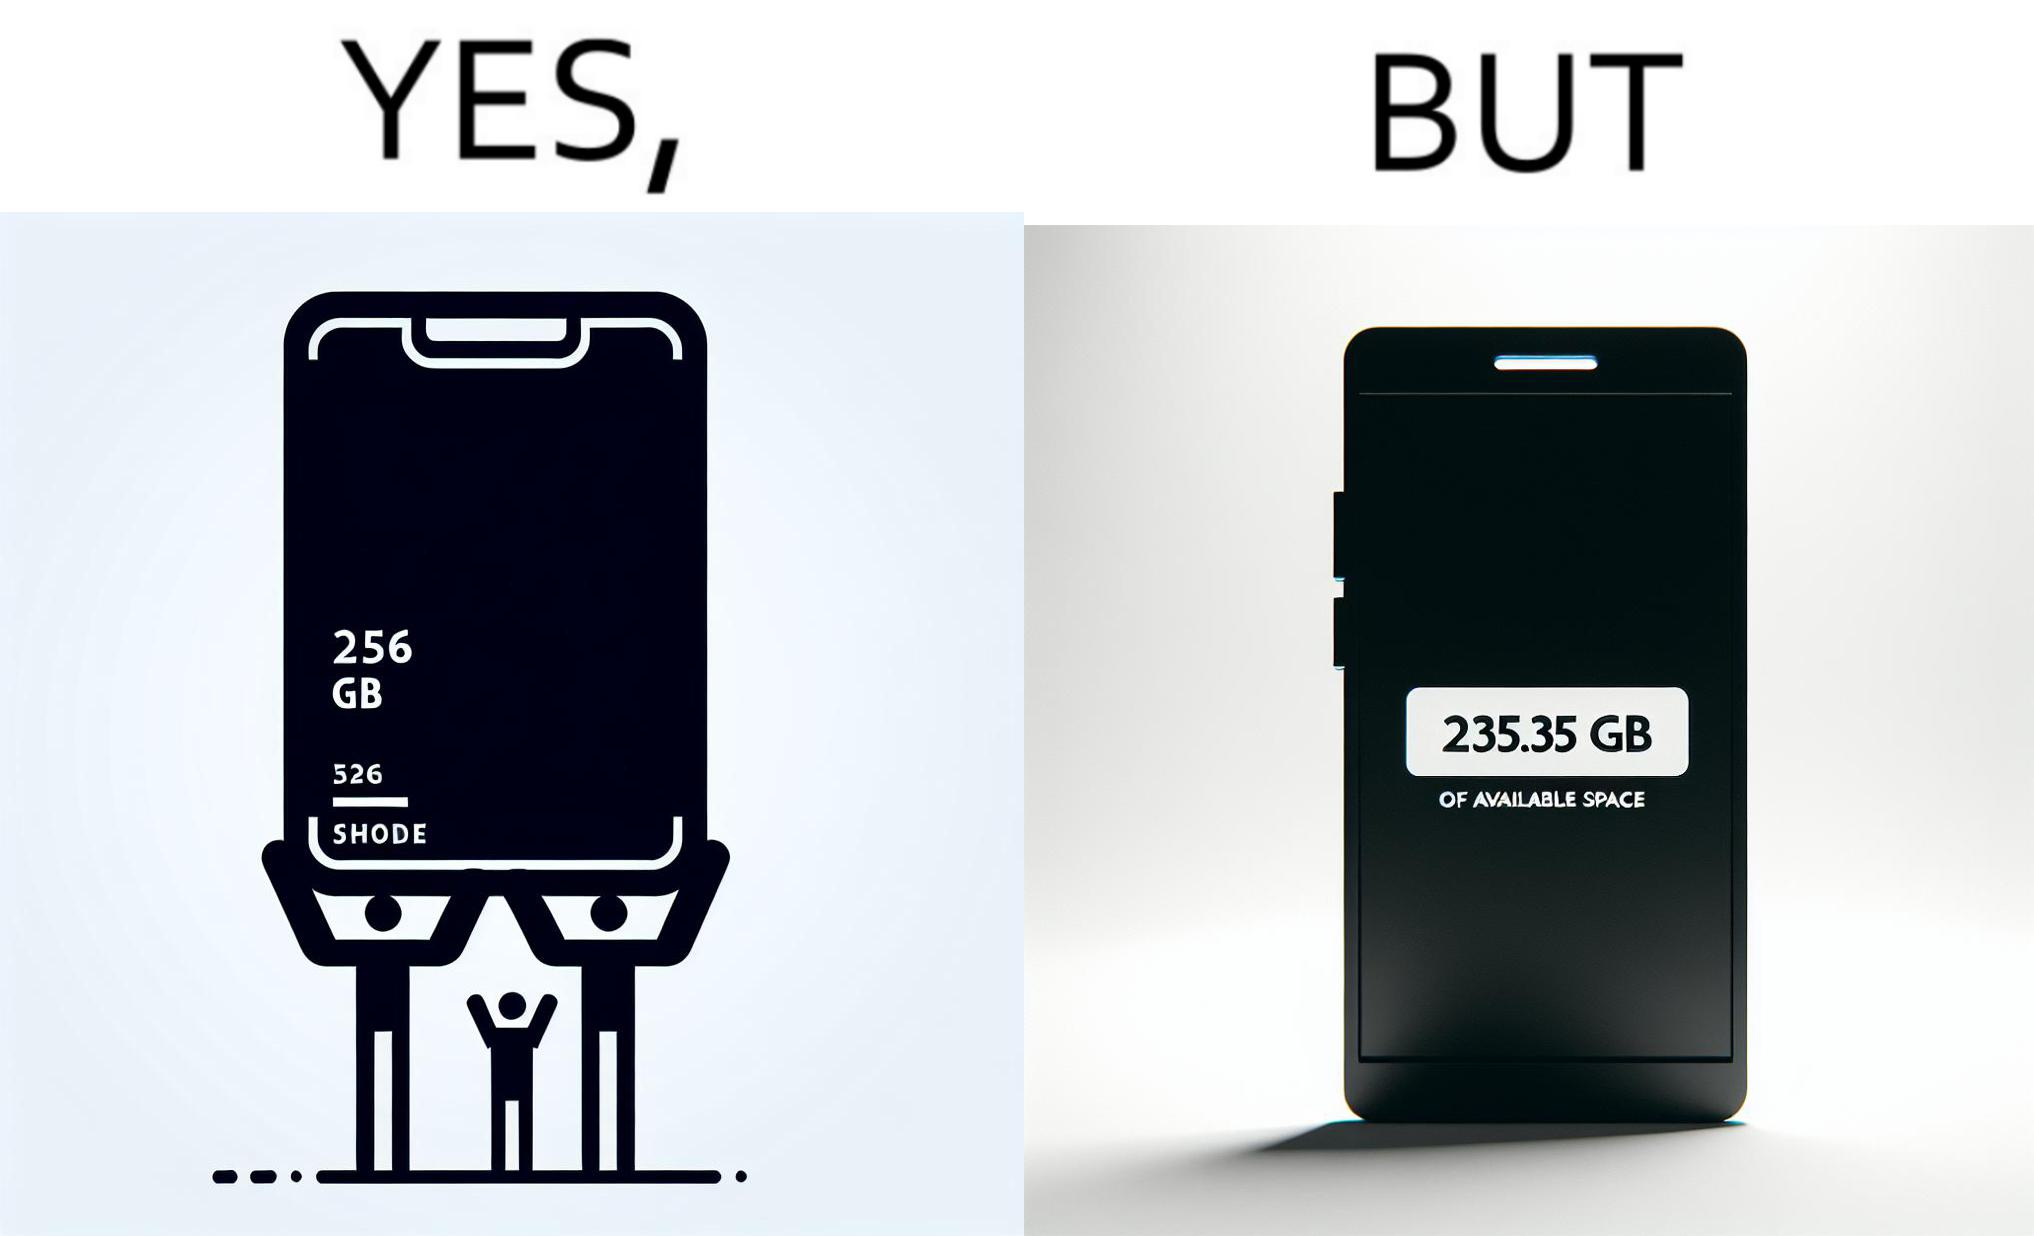Describe what you see in the left and right parts of this image. In the left part of the image: It is a smartphone box claiming the phone has a storage capacity of 256 gb In the right part of the image: It is a smartphone with 235.35 gb of available space 